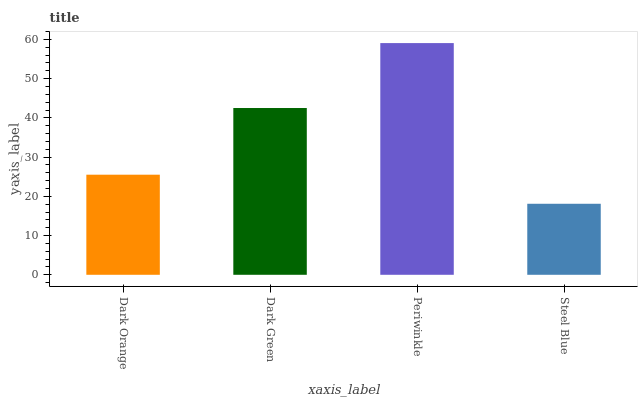Is Steel Blue the minimum?
Answer yes or no. Yes. Is Periwinkle the maximum?
Answer yes or no. Yes. Is Dark Green the minimum?
Answer yes or no. No. Is Dark Green the maximum?
Answer yes or no. No. Is Dark Green greater than Dark Orange?
Answer yes or no. Yes. Is Dark Orange less than Dark Green?
Answer yes or no. Yes. Is Dark Orange greater than Dark Green?
Answer yes or no. No. Is Dark Green less than Dark Orange?
Answer yes or no. No. Is Dark Green the high median?
Answer yes or no. Yes. Is Dark Orange the low median?
Answer yes or no. Yes. Is Steel Blue the high median?
Answer yes or no. No. Is Steel Blue the low median?
Answer yes or no. No. 